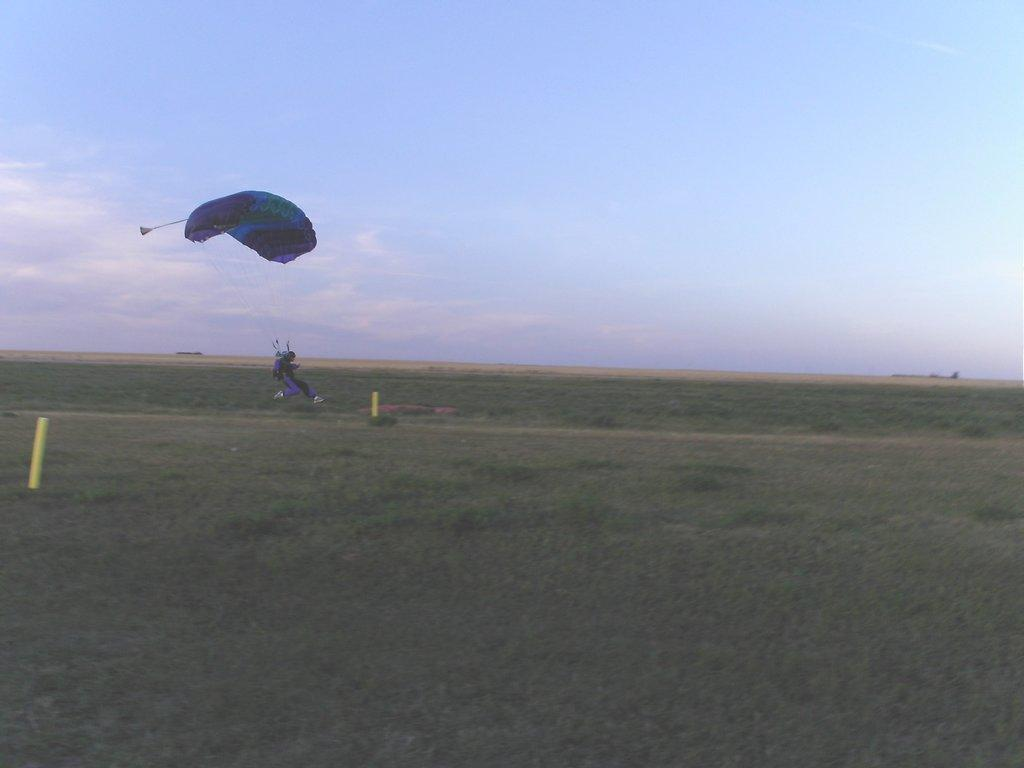What is the person in the image doing? The person is using a parachute in the image. What is the result of the person's action? The person is landing on the ground. Are there any objects on the ground in the image? Yes, there are two yellow poles on the ground. What type of pickle is the person holding while parachuting in the image? There is no pickle present in the image; the person is using a parachute and landing on the ground. How many apples can be seen on the person's face in the image? There are no apples present on the person's face in the image. 